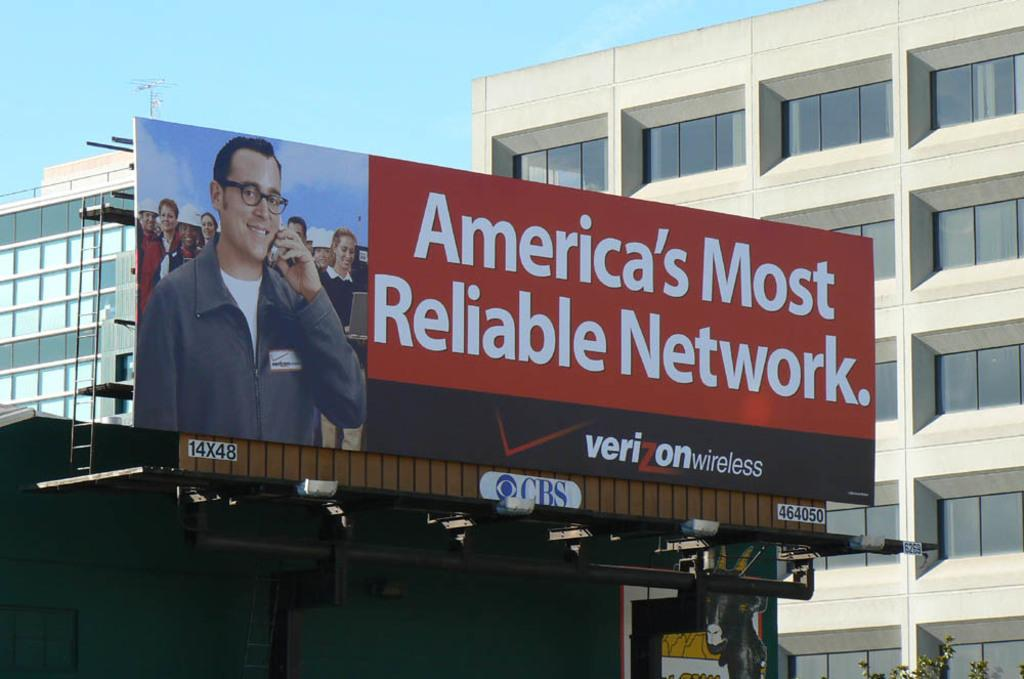<image>
Offer a succinct explanation of the picture presented. a billboard sign that says 'americas most reliable network.' on it 